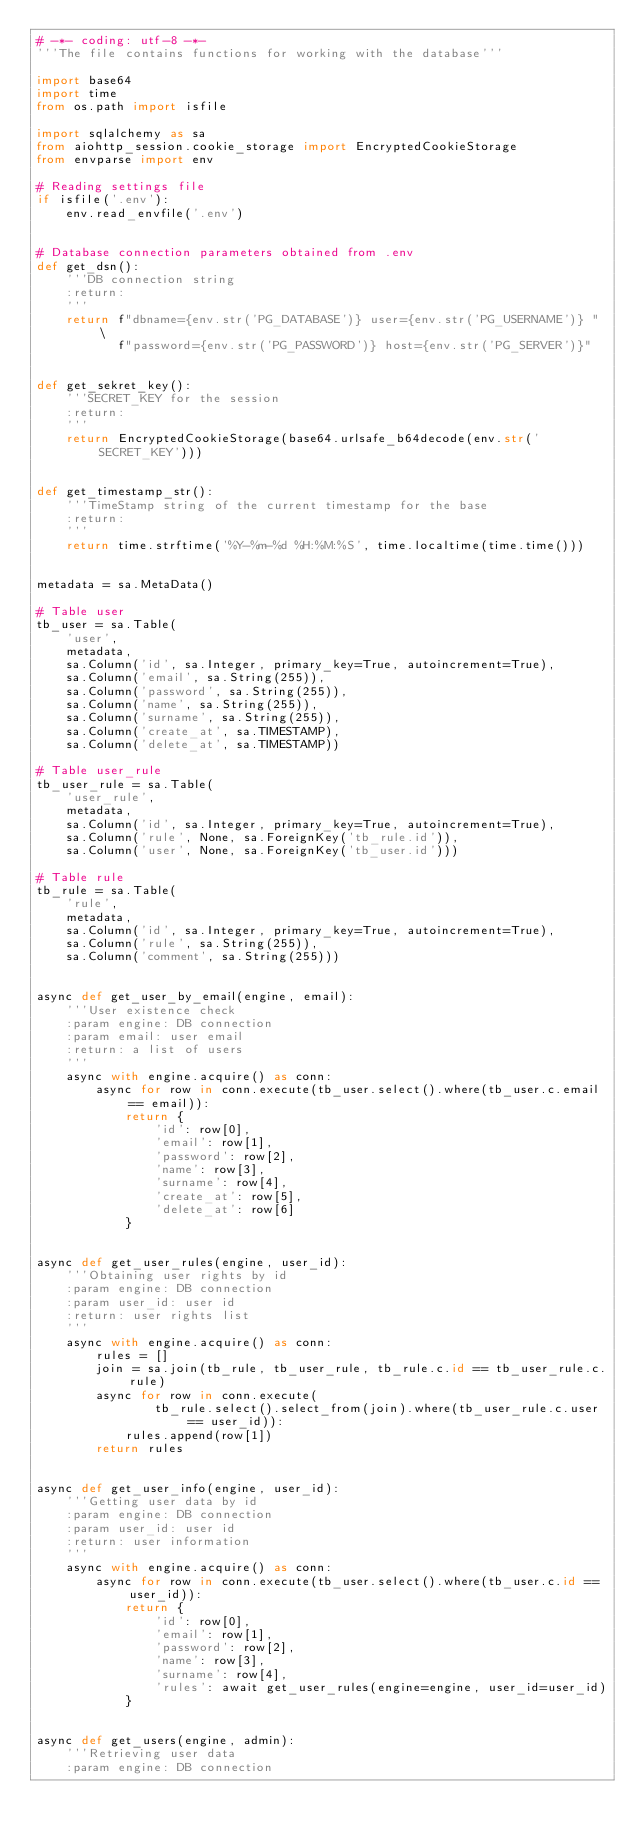Convert code to text. <code><loc_0><loc_0><loc_500><loc_500><_Python_># -*- coding: utf-8 -*-
'''The file contains functions for working with the database'''

import base64
import time
from os.path import isfile

import sqlalchemy as sa
from aiohttp_session.cookie_storage import EncryptedCookieStorage
from envparse import env

# Reading settings file
if isfile('.env'):
    env.read_envfile('.env')


# Database connection parameters obtained from .env
def get_dsn():
    '''DB connection string
    :return:
    '''
    return f"dbname={env.str('PG_DATABASE')} user={env.str('PG_USERNAME')} " \
           f"password={env.str('PG_PASSWORD')} host={env.str('PG_SERVER')}"


def get_sekret_key():
    '''SECRET_KEY for the session
    :return:
    '''
    return EncryptedCookieStorage(base64.urlsafe_b64decode(env.str('SECRET_KEY')))


def get_timestamp_str():
    '''TimeStamp string of the current timestamp for the base
    :return:
    '''
    return time.strftime('%Y-%m-%d %H:%M:%S', time.localtime(time.time()))


metadata = sa.MetaData()

# Table user
tb_user = sa.Table(
    'user',
    metadata,
    sa.Column('id', sa.Integer, primary_key=True, autoincrement=True),
    sa.Column('email', sa.String(255)),
    sa.Column('password', sa.String(255)),
    sa.Column('name', sa.String(255)),
    sa.Column('surname', sa.String(255)),
    sa.Column('create_at', sa.TIMESTAMP),
    sa.Column('delete_at', sa.TIMESTAMP))

# Table user_rule
tb_user_rule = sa.Table(
    'user_rule',
    metadata,
    sa.Column('id', sa.Integer, primary_key=True, autoincrement=True),
    sa.Column('rule', None, sa.ForeignKey('tb_rule.id')),
    sa.Column('user', None, sa.ForeignKey('tb_user.id')))

# Table rule
tb_rule = sa.Table(
    'rule',
    metadata,
    sa.Column('id', sa.Integer, primary_key=True, autoincrement=True),
    sa.Column('rule', sa.String(255)),
    sa.Column('comment', sa.String(255)))


async def get_user_by_email(engine, email):
    '''User existence check
    :param engine: DB connection
    :param email: user email
    :return: a list of users
    '''
    async with engine.acquire() as conn:
        async for row in conn.execute(tb_user.select().where(tb_user.c.email == email)):
            return {
                'id': row[0],
                'email': row[1],
                'password': row[2],
                'name': row[3],
                'surname': row[4],
                'create_at': row[5],
                'delete_at': row[6]
            }


async def get_user_rules(engine, user_id):
    '''Obtaining user rights by id
    :param engine: DB connection
    :param user_id: user id
    :return: user rights list
    '''
    async with engine.acquire() as conn:
        rules = []
        join = sa.join(tb_rule, tb_user_rule, tb_rule.c.id == tb_user_rule.c.rule)
        async for row in conn.execute(
                tb_rule.select().select_from(join).where(tb_user_rule.c.user == user_id)):
            rules.append(row[1])
        return rules


async def get_user_info(engine, user_id):
    '''Getting user data by id
    :param engine: DB connection
    :param user_id: user id
    :return: user information
    '''
    async with engine.acquire() as conn:
        async for row in conn.execute(tb_user.select().where(tb_user.c.id == user_id)):
            return {
                'id': row[0],
                'email': row[1],
                'password': row[2],
                'name': row[3],
                'surname': row[4],
                'rules': await get_user_rules(engine=engine, user_id=user_id)
            }


async def get_users(engine, admin):
    '''Retrieving user data
    :param engine: DB connection</code> 